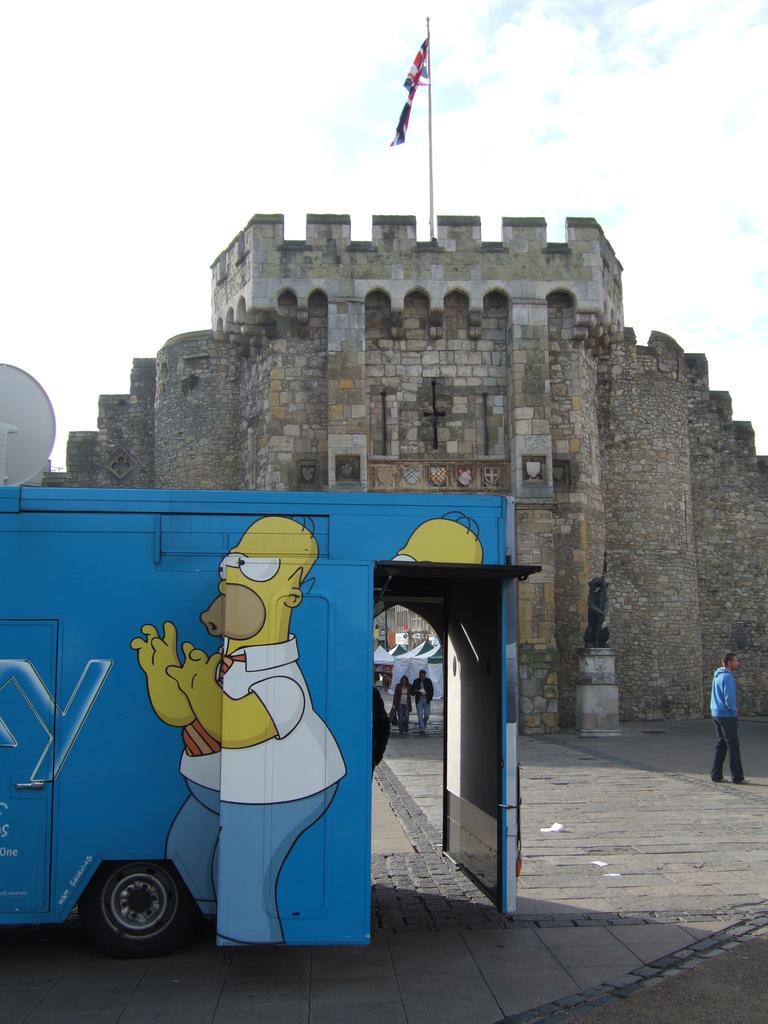Could you give a brief overview of what you see in this image? In this picture there is a building in the center of the image and there is a flag on it and there is a bus on the left side of the image. 